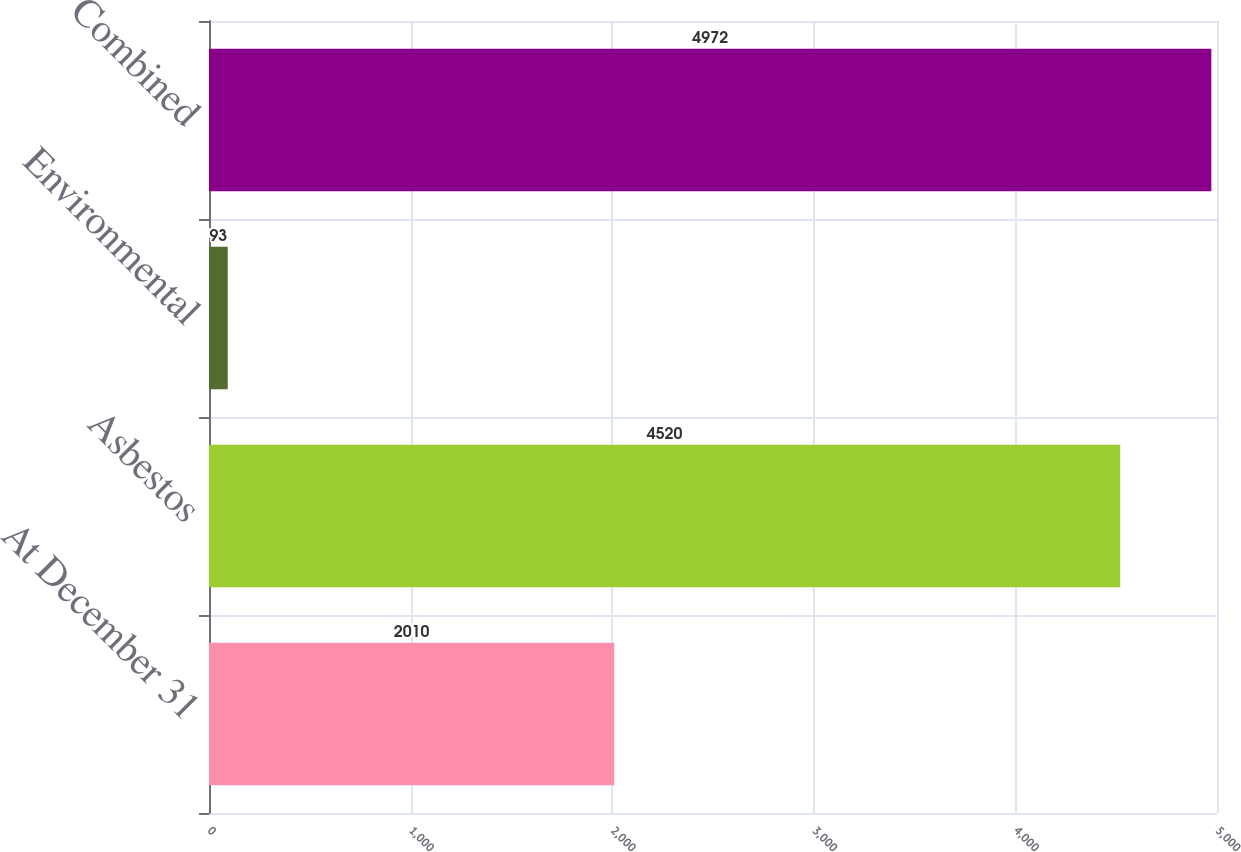<chart> <loc_0><loc_0><loc_500><loc_500><bar_chart><fcel>At December 31<fcel>Asbestos<fcel>Environmental<fcel>Combined<nl><fcel>2010<fcel>4520<fcel>93<fcel>4972<nl></chart> 